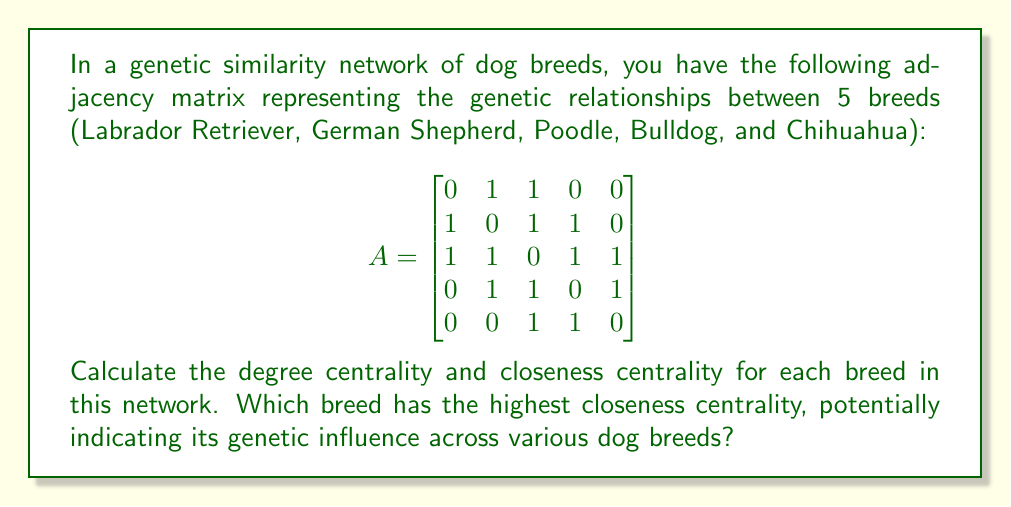Teach me how to tackle this problem. To solve this problem, we'll calculate both degree centrality and closeness centrality for each breed in the network.

1. Degree Centrality:
Degree centrality is simply the number of connections each node (breed) has.

- Labrador Retriever: 2 connections
- German Shepherd: 3 connections
- Poodle: 4 connections
- Bulldog: 3 connections
- Chihuahua: 2 connections

2. Closeness Centrality:
Closeness centrality is calculated as the reciprocal of the sum of the shortest path distances from a node to all other nodes.

First, we need to calculate the shortest path distances:

$$
\text{Distance Matrix} = \begin{bmatrix}
0 & 1 & 1 & 2 & 2 \\
1 & 0 & 1 & 1 & 2 \\
1 & 1 & 0 & 1 & 1 \\
2 & 1 & 1 & 0 & 1 \\
2 & 2 & 1 & 1 & 0
\end{bmatrix}
$$

Now, we can calculate closeness centrality for each breed:

Closeness Centrality = $\frac{n-1}{\sum_{j=1}^n d_{ij}}$, where $n$ is the number of nodes and $d_{ij}$ is the distance from node $i$ to node $j$.

- Labrador Retriever: $\frac{4}{1+1+2+2} = \frac{4}{6} = 0.667$
- German Shepherd: $\frac{4}{1+1+1+2} = \frac{4}{5} = 0.800$
- Poodle: $\frac{4}{1+1+1+1} = \frac{4}{4} = 1.000$
- Bulldog: $\frac{4}{2+1+1+1} = \frac{4}{5} = 0.800$
- Chihuahua: $\frac{4}{2+2+1+1} = \frac{4}{6} = 0.667$
Answer: Degree Centrality:
Labrador Retriever: 2
German Shepherd: 3
Poodle: 4
Bulldog: 3
Chihuahua: 2

Closeness Centrality:
Labrador Retriever: 0.667
German Shepherd: 0.800
Poodle: 1.000
Bulldog: 0.800
Chihuahua: 0.667

The Poodle has the highest closeness centrality (1.000), indicating it has the most central position in the genetic similarity network and potentially the most genetic influence across various dog breeds. 